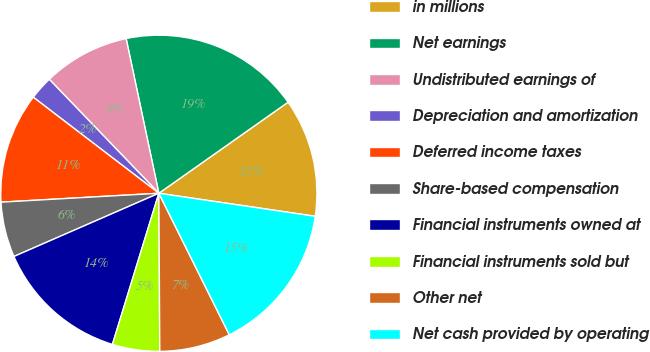<chart> <loc_0><loc_0><loc_500><loc_500><pie_chart><fcel>in millions<fcel>Net earnings<fcel>Undistributed earnings of<fcel>Depreciation and amortization<fcel>Deferred income taxes<fcel>Share-based compensation<fcel>Financial instruments owned at<fcel>Financial instruments sold but<fcel>Other net<fcel>Net cash provided by operating<nl><fcel>12.1%<fcel>18.55%<fcel>8.87%<fcel>2.42%<fcel>11.29%<fcel>5.65%<fcel>13.71%<fcel>4.84%<fcel>7.26%<fcel>15.32%<nl></chart> 